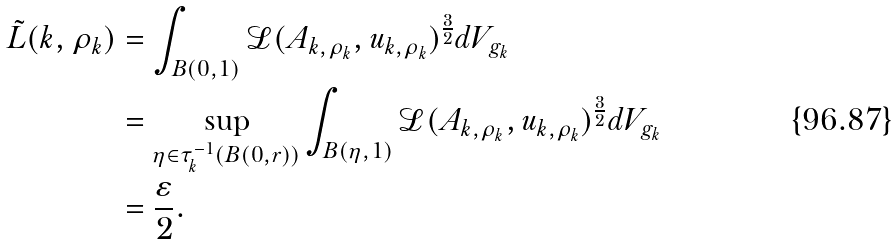<formula> <loc_0><loc_0><loc_500><loc_500>\tilde { L } ( k , \rho _ { k } ) & = \int _ { B ( 0 , 1 ) } \mathcal { L } ( A _ { k , \rho _ { k } } , u _ { k , \rho _ { k } } ) ^ { \frac { 3 } { 2 } } d V _ { g _ { k } } \\ & = \sup _ { \eta \in \tau _ { k } ^ { - 1 } ( B ( 0 , r ) ) } \int _ { B ( \eta , 1 ) } \mathcal { L } ( A _ { k , \rho _ { k } } , u _ { k , \rho _ { k } } ) ^ { \frac { 3 } { 2 } } d V _ { g _ { k } } \\ & = \frac { \varepsilon } { 2 } .</formula> 